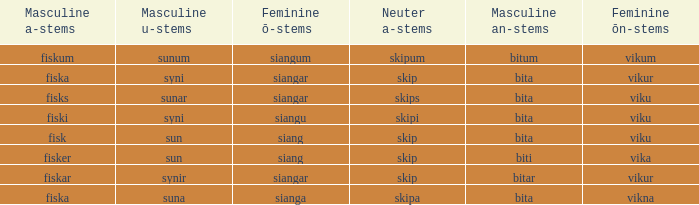What is the an-stem for the expression that has an ö-stems of siangar and an u-stem finish of syni? Bita. 